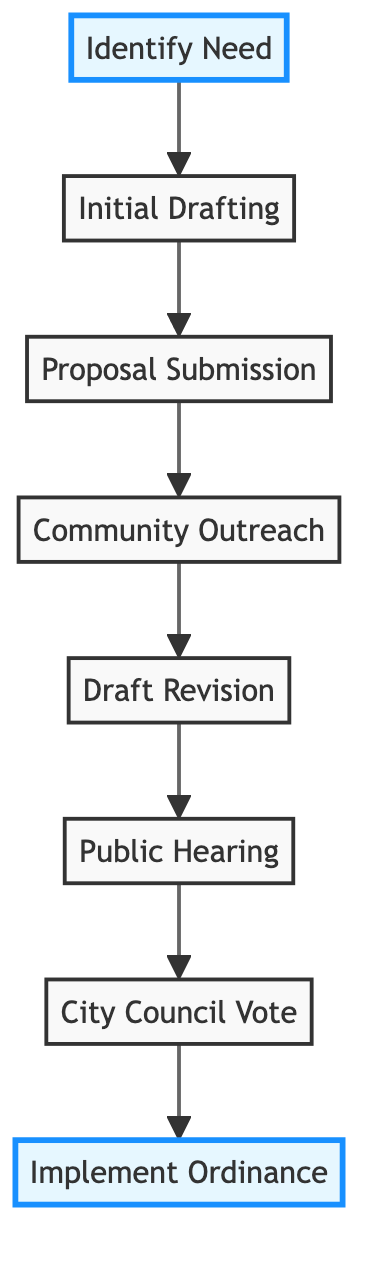What is the first step in the process? The first step in the flowchart is "Identify Need," which indicates the initiation of the ordinance process.
Answer: Identify Need How many total steps are involved in this process? Counting all the steps in the diagram, there are 8 distinct steps listed for getting a new local ordinance approved.
Answer: 8 What is the last step in the process? The last step is "Implement Ordinance," which signifies the final action of enacting the ordinance after approval.
Answer: Implement Ordinance Which step comes right after "Proposal Submission"? The step that follows "Proposal Submission" is "Community Outreach," as indicated by the flow from one step to the next in the diagram.
Answer: Community Outreach What is the relationship between "Draft Revision" and "Public Hearing"? "Draft Revision" precedes "Public Hearing" in the flowchart, indicating that the draft is revised before gathering public feedback.
Answer: Draft Revision precedes Public Hearing Which step requires community feedback? The step "Public Hearing" involves gathering feedback and opinions from community members, as explicitly described in the flowchart.
Answer: Public Hearing How many steps are there between "Identify Need" and "Implement Ordinance"? There are 6 steps that flow between "Identify Need" and "Implement Ordinance," connecting the initiation to the final implementation.
Answer: 6 What is the role of Andy Weissman in the process? Andy Weissman is involved during the "Draft Revision" step, where consultations occur to refine the ordinance based on stakeholder input.
Answer: Consultations for Draft Revision What happens during the "Community Outreach" step? During "Community Outreach," the process focuses on engaging local community members and leaders to gather support and feedback.
Answer: Engage with local community members and leaders 